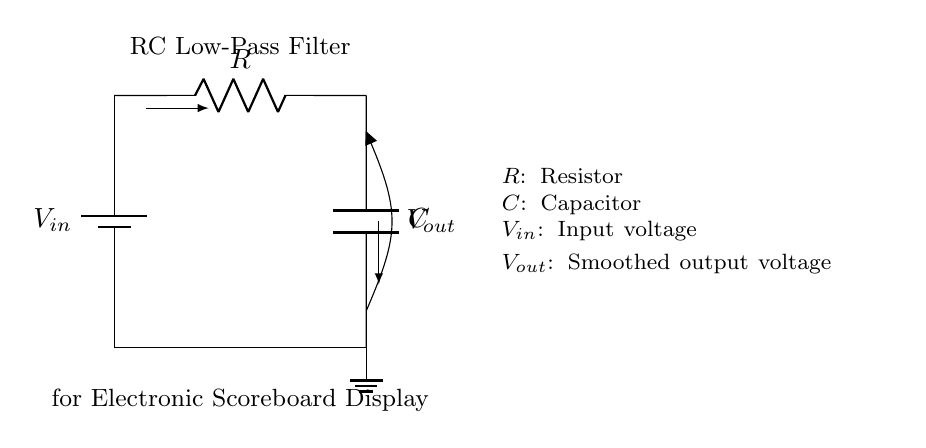What type of filter is this circuit? This circuit is classified as a low-pass filter, which is indicated by its design featuring a resistor and a capacitor arranged in such a way to allow low-frequency signals to pass while attenuating high-frequency signals.
Answer: low-pass filter What components are used in this circuit? The diagram includes a resistor denoted as R and a capacitor denoted as C, which are essential components of an RC low-pass filter.
Answer: R and C What is the purpose of the capacitor in this circuit? The capacitor acts to smooth out fluctuations by charging and discharging, effectively filtering high-frequency noise and allowing the low-frequency signals to appear at the output.
Answer: Smoothing fluctuations What is the output voltage dependent on? The output voltage, denoted as Vout, depends on the input voltage Vin, the resistor R, and the capacitor C, specifically due to the time constant created by R and C affecting how the capacitor charges and discharges.
Answer: R and C What happens to high-frequency signals in this circuit? High-frequency signals are attenuated or reduced in amplitude as they are blocked by the combination of the resistor and capacitor, allowing primarily low-frequency signals to pass through to the output.
Answer: Attenuated At what point in the circuit is Vout measured? Vout is measured across the capacitor C, which is positioned between the output terminal and ground, providing the smoothed voltage signal for use in the scoreboard display.
Answer: Across the capacitor 